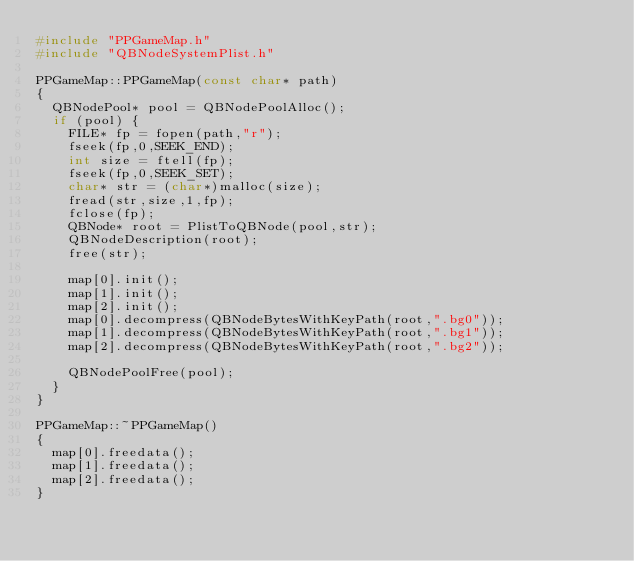<code> <loc_0><loc_0><loc_500><loc_500><_C++_>#include "PPGameMap.h"
#include "QBNodeSystemPlist.h"

PPGameMap::PPGameMap(const char* path)
{
	QBNodePool* pool = QBNodePoolAlloc();
	if (pool) {
		FILE* fp = fopen(path,"r");
		fseek(fp,0,SEEK_END);
		int size = ftell(fp);
		fseek(fp,0,SEEK_SET);
		char* str = (char*)malloc(size);
		fread(str,size,1,fp);
		fclose(fp);
		QBNode* root = PlistToQBNode(pool,str);
		QBNodeDescription(root);
		free(str);
		
		map[0].init();
		map[1].init();
		map[2].init();
		map[0].decompress(QBNodeBytesWithKeyPath(root,".bg0"));
		map[1].decompress(QBNodeBytesWithKeyPath(root,".bg1"));
		map[2].decompress(QBNodeBytesWithKeyPath(root,".bg2"));
		
		QBNodePoolFree(pool);
	}
}

PPGameMap::~PPGameMap()
{
	map[0].freedata();
	map[1].freedata();
	map[2].freedata();
}
</code> 